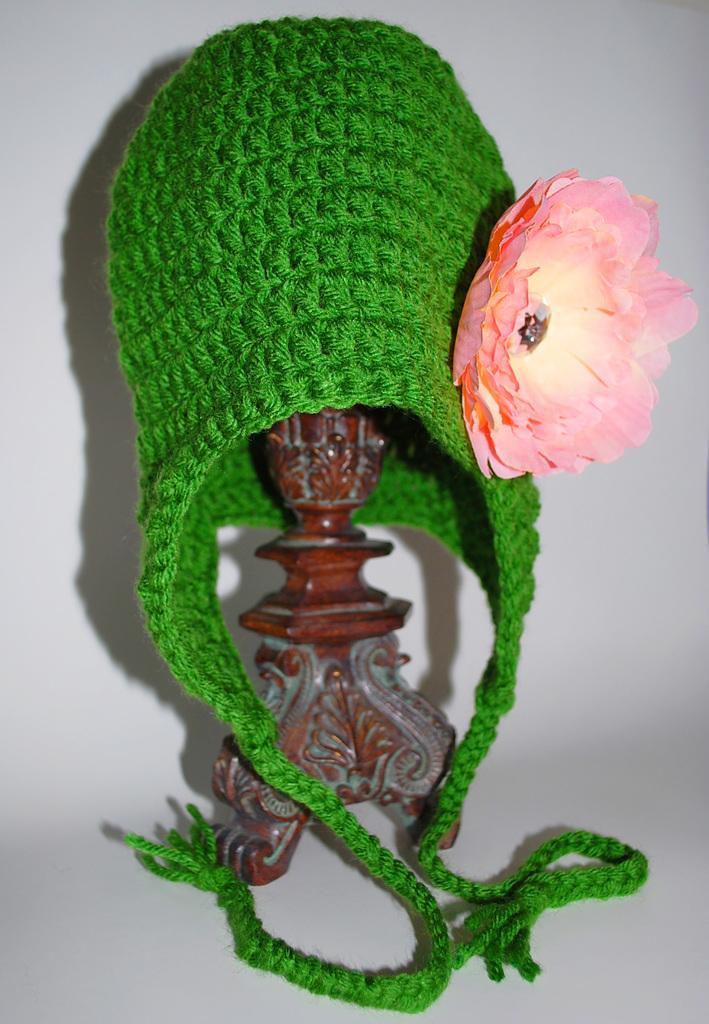Please provide a concise description of this image. In this image we can see a woolen cap with a flower on a stand which is placed on the surface. 